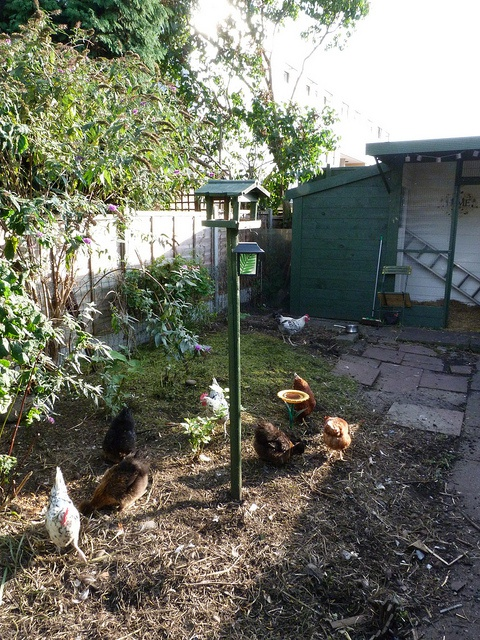Describe the objects in this image and their specific colors. I can see bird in black, maroon, and gray tones, bird in black, white, darkgray, and gray tones, bird in black, gray, and maroon tones, bird in black and gray tones, and bird in black, maroon, beige, and tan tones in this image. 